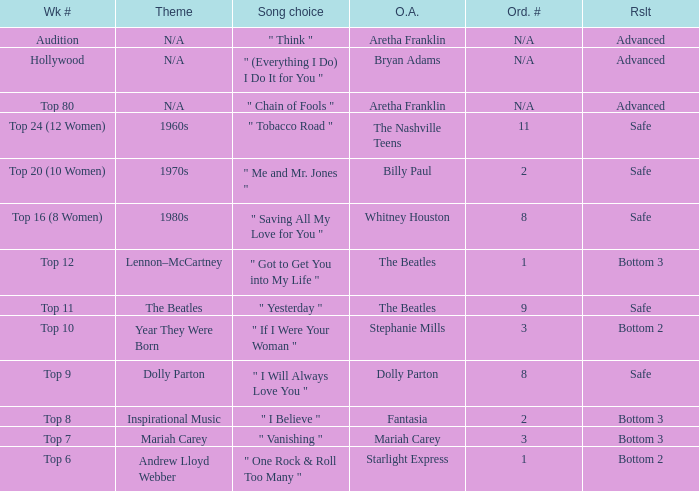Name the week number for andrew lloyd webber Top 6. 